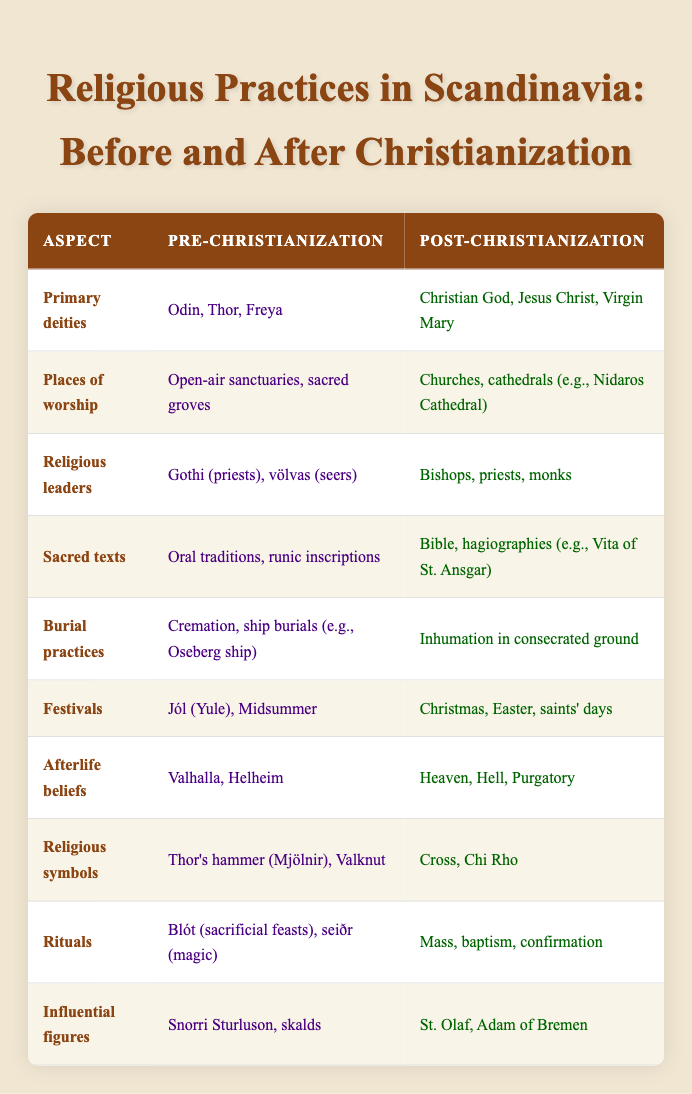What are the primary deities in Scandinavia before Christianization? According to the table, the primary deities before Christianization were Odin, Thor, and Freya.
Answer: Odin, Thor, Freya What is the place of worship used in Scandinavia after Christianization? The table lists churches and cathedrals, such as Nidaros Cathedral, as the places of worship after Christianization.
Answer: Churches, cathedrals (e.g., Nidaros Cathedral) True or false: The burial practice in Scandinavia after Christianization involved cremation. The table shows that burial practices changed to inhumation in consecrated ground after Christianization, indicating that cremation was not the practice used then.
Answer: False What is the difference in the afterlife beliefs between pre-Christianization and post-Christianization? After examining the table, the pre-Christian beliefs included Valhalla and Helheim, while post-Christian beliefs shifted to Heaven, Hell, and Purgatory. The difference lies in the specific realms they believed in for afterlife.
Answer: Valhalla, Helheim; Heaven, Hell, Purgatory Which religious symbols were significant in pre-Christian Scandinavian practices? The table lists Thor's hammer (Mjölnir) and Valknut as the significant religious symbols before Christianization.
Answer: Thor's hammer (Mjölnir), Valknut Identify the influential figures in Scandinavian religion during the pre-Christianization period. According to the table, Snorri Sturluson and skalds were the influential figures during the pre-Christianization period.
Answer: Snorri Sturluson, skalds How many major festivals were mentioned for pre-Christianization and post-Christianization? The pre-Christianization festivals listed are Jól (Yule) and Midsummer, totaling 2; while post-Christian festivals listed are Christmas, Easter, and saints' days, totaling 3. Therefore, there is a change in the number of major festivals from 2 to 3.
Answer: Pre-Christianization: 2; Post-Christianization: 3 What change occurred in the religious leaders' roles after Christianization? The table shows that religious leaders before Christianization were Gothi and völvas, while post-Christianization saw bishops, priests, and monks taking on these roles, indicating a shift from pagan to Christian clerical structures.
Answer: Gothi, völvas to bishops, priests, monks What are the sacred texts used in Scandinavia before and after Christianization? Before Christianization, the sacred texts included oral traditions and runic inscriptions, while after Christianization, the texts shifted to the Bible and hagiographies like the Vita of St. Ansgar.
Answer: Oral traditions, runic inscriptions; Bible, hagiographies (e.g., Vita of St. Ansgar) 